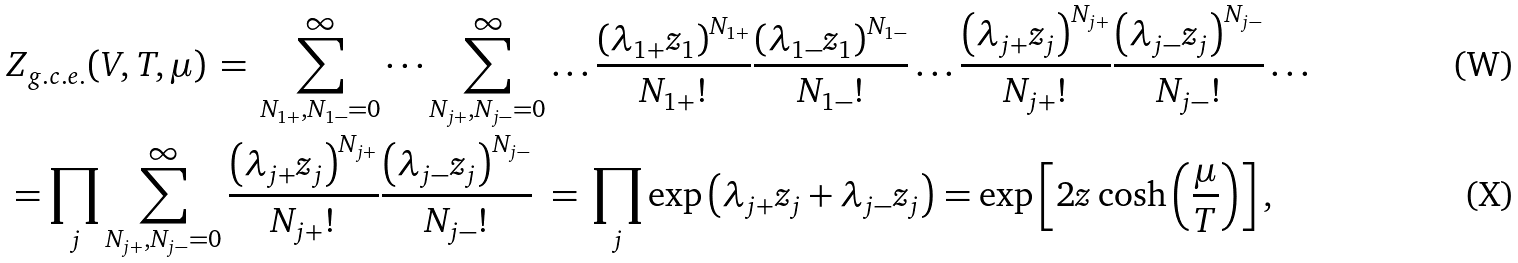<formula> <loc_0><loc_0><loc_500><loc_500>& Z _ { g . c . e . } ( V , T , \mu ) \, = \, \sum _ { N _ { 1 + } , N _ { 1 - } = 0 } ^ { \infty } \dots \sum _ { N _ { j + } , N _ { j - } = 0 } ^ { \infty } \dots \frac { \left ( \lambda _ { 1 + } z _ { 1 } \right ) ^ { N _ { 1 + } } } { N _ { 1 + } ! } \frac { \left ( \lambda _ { 1 - } z _ { 1 } \right ) ^ { N _ { 1 - } } } { N _ { 1 - } ! } \dots \frac { \left ( \lambda _ { j + } z _ { j } \right ) ^ { N _ { j + } } } { N _ { j + } ! } \frac { \left ( \lambda _ { j - } z _ { j } \right ) ^ { N _ { j - } } } { N _ { j - } ! } \dots \\ & = \prod _ { j } \sum _ { N _ { j + } , N _ { j - } = 0 } ^ { \infty } \frac { \left ( \lambda _ { j + } z _ { j } \right ) ^ { N _ { j + } } } { N _ { j + } ! } \frac { \left ( \lambda _ { j - } z _ { j } \right ) ^ { N _ { j - } } } { N _ { j - } ! } \ = \, \prod _ { j } \exp \left ( \lambda _ { j + } z _ { j } + \lambda _ { j - } z _ { j } \right ) = \exp \left [ 2 z \cosh \left ( \frac { \mu } { T } \right ) \right ] ,</formula> 